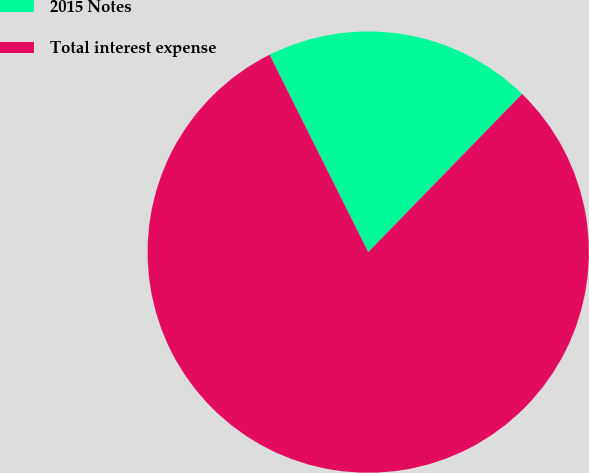Convert chart. <chart><loc_0><loc_0><loc_500><loc_500><pie_chart><fcel>2015 Notes<fcel>Total interest expense<nl><fcel>19.66%<fcel>80.34%<nl></chart> 